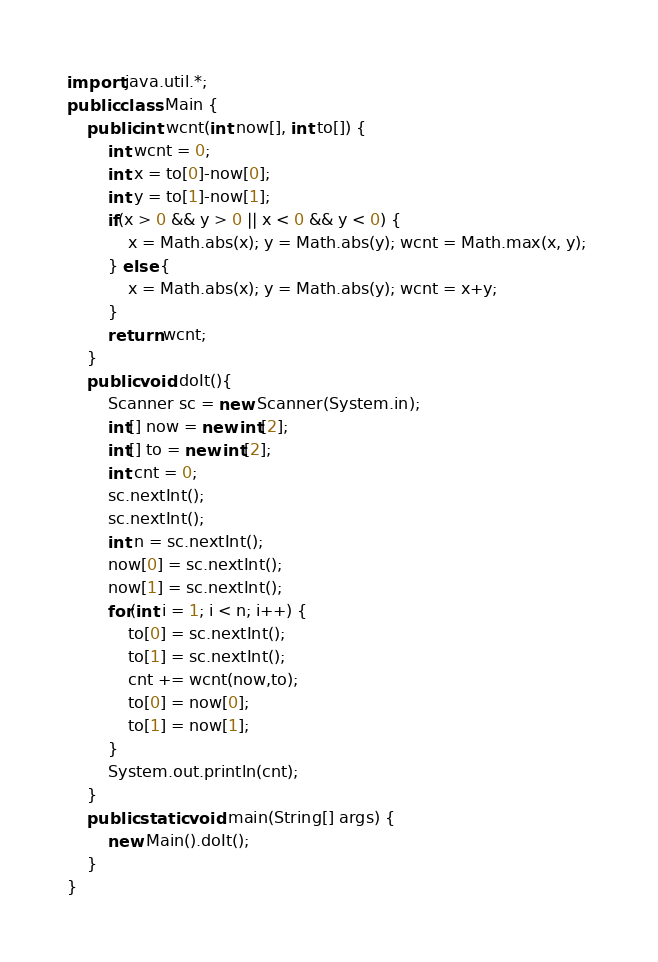Convert code to text. <code><loc_0><loc_0><loc_500><loc_500><_Java_>
import java.util.*;
public class Main {
	public int wcnt(int now[], int to[]) {
		int wcnt = 0;
		int x = to[0]-now[0];
		int y = to[1]-now[1];
		if(x > 0 && y > 0 || x < 0 && y < 0) { 
			x = Math.abs(x); y = Math.abs(y); wcnt = Math.max(x, y); 
		} else { 
			x = Math.abs(x); y = Math.abs(y); wcnt = x+y;
		}
		return wcnt;
	}
	public void doIt(){
		Scanner sc = new Scanner(System.in);
		int[] now = new int[2];
		int[] to = new int[2];
		int cnt = 0;
		sc.nextInt();
		sc.nextInt();
		int n = sc.nextInt();
		now[0] = sc.nextInt();
		now[1] = sc.nextInt();
		for(int i = 1; i < n; i++) {
			to[0] = sc.nextInt();
			to[1] = sc.nextInt();
			cnt += wcnt(now,to);
			to[0] = now[0];
			to[1] = now[1];
		}
		System.out.println(cnt);
	}
	public static void main(String[] args) {
		new Main().doIt();
	}
}</code> 